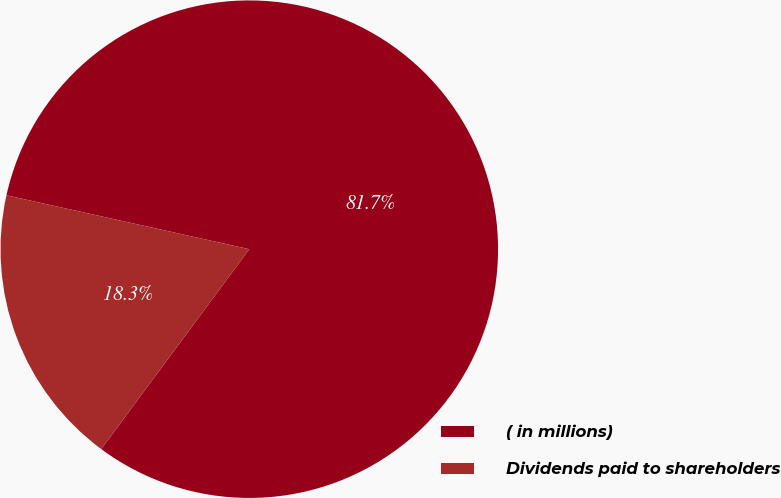Convert chart to OTSL. <chart><loc_0><loc_0><loc_500><loc_500><pie_chart><fcel>( in millions)<fcel>Dividends paid to shareholders<nl><fcel>81.67%<fcel>18.33%<nl></chart> 